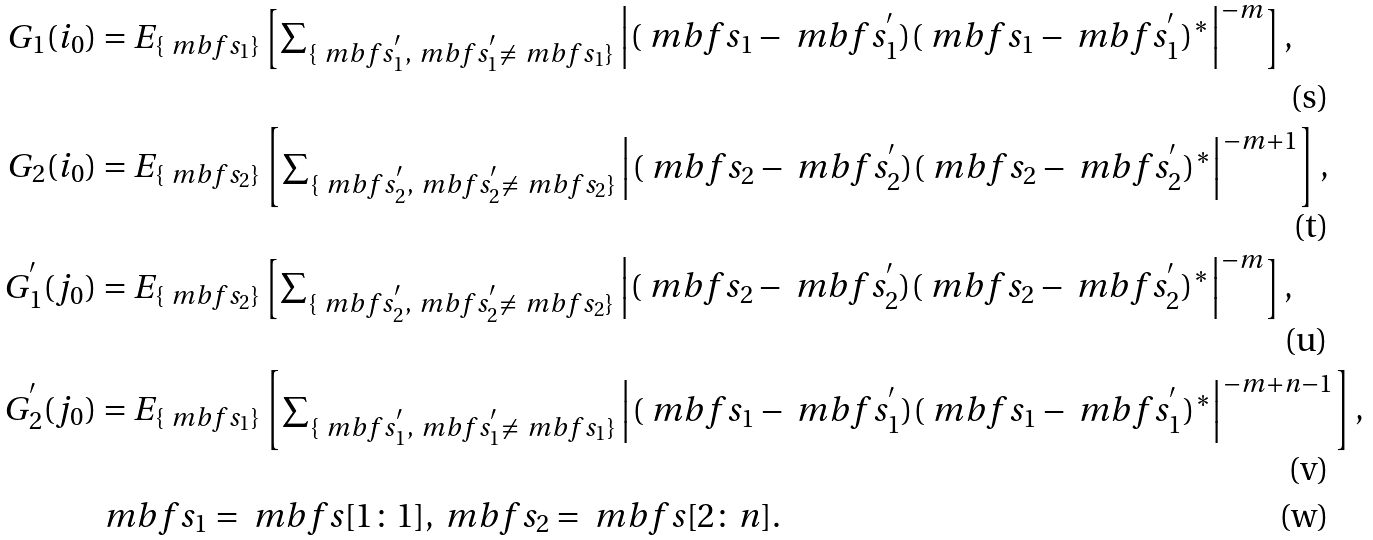<formula> <loc_0><loc_0><loc_500><loc_500>G _ { 1 } ( i _ { 0 } ) & = E _ { \{ \ m b f { s } _ { 1 } \} } \begin{bmatrix} \sum _ { \{ \ m b f { s } ^ { ^ { \prime } } _ { 1 } , \ m b f { s } ^ { ^ { \prime } } _ { 1 } \neq \ m b f { s } _ { 1 } \} } \Big { | } ( \ m b f { s } _ { 1 } - \ m b f { s } _ { 1 } ^ { ^ { \prime } } ) ( \ m b f { s } _ { 1 } - \ m b f { s } _ { 1 } ^ { ^ { \prime } } ) ^ { * } \Big { | } ^ { - m } \end{bmatrix} , \\ G _ { 2 } ( i _ { 0 } ) & = E _ { \{ \ m b f { s } _ { 2 } \} } \begin{bmatrix} \sum _ { \{ \ m b f { s } ^ { ^ { \prime } } _ { 2 } , \ m b f { s } ^ { ^ { \prime } } _ { 2 } \neq \ m b f { s } _ { 2 } \} } \Big { | } ( \ m b f { s } _ { 2 } - \ m b f { s } _ { 2 } ^ { ^ { \prime } } ) ( \ m b f { s } _ { 2 } - \ m b f { s } _ { 2 } ^ { ^ { \prime } } ) ^ { * } \Big { | } ^ { - m + 1 } \end{bmatrix} , \\ G _ { 1 } ^ { ^ { \prime } } ( j _ { 0 } ) & = E _ { \{ \ m b f { s } _ { 2 } \} } \begin{bmatrix} \sum _ { \{ \ m b f { s } ^ { ^ { \prime } } _ { 2 } , \ m b f { s } ^ { ^ { \prime } } _ { 2 } \neq \ m b f { s } _ { 2 } \} } \Big { | } ( \ m b f { s } _ { 2 } - \ m b f { s } _ { 2 } ^ { ^ { \prime } } ) ( \ m b f { s } _ { 2 } - \ m b f { s } _ { 2 } ^ { ^ { \prime } } ) ^ { * } \Big { | } ^ { - m } \end{bmatrix} , \\ G _ { 2 } ^ { ^ { \prime } } ( j _ { 0 } ) & = E _ { \{ \ m b f { s } _ { 1 } \} } \begin{bmatrix} \sum _ { \{ \ m b f { s } ^ { ^ { \prime } } _ { 1 } , \ m b f { s } ^ { ^ { \prime } } _ { 1 } \neq \ m b f { s } _ { 1 } \} } \Big { | } ( \ m b f { s } _ { 1 } - \ m b f { s } _ { 1 } ^ { ^ { \prime } } ) ( \ m b f { s } _ { 1 } - \ m b f { s } _ { 1 } ^ { ^ { \prime } } ) ^ { * } \Big { | } ^ { - m + n - 1 } \end{bmatrix} , \\ & \ m b f { s } _ { 1 } = \ m b f { s } [ 1 \colon 1 ] , \ m b f { s } _ { 2 } = \ m b f { s } [ 2 \colon n ] .</formula> 